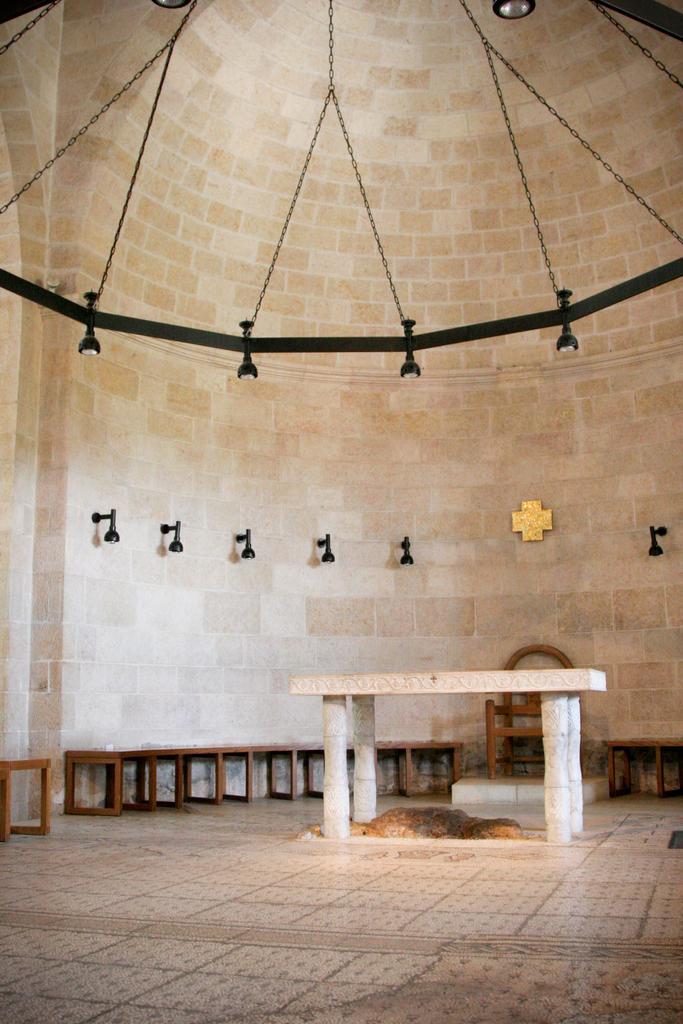Please provide a concise description of this image. In this picture we can see benches on the ground and in the background we can see a wall, lights and some objects. 